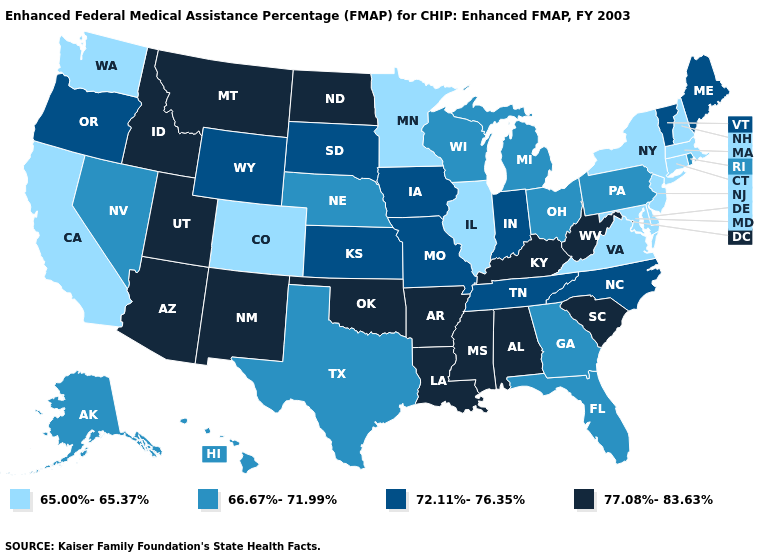Name the states that have a value in the range 77.08%-83.63%?
Keep it brief. Alabama, Arizona, Arkansas, Idaho, Kentucky, Louisiana, Mississippi, Montana, New Mexico, North Dakota, Oklahoma, South Carolina, Utah, West Virginia. What is the value of Rhode Island?
Keep it brief. 66.67%-71.99%. Which states have the highest value in the USA?
Write a very short answer. Alabama, Arizona, Arkansas, Idaho, Kentucky, Louisiana, Mississippi, Montana, New Mexico, North Dakota, Oklahoma, South Carolina, Utah, West Virginia. What is the value of New Mexico?
Write a very short answer. 77.08%-83.63%. Among the states that border Washington , which have the highest value?
Quick response, please. Idaho. What is the value of Washington?
Keep it brief. 65.00%-65.37%. Which states hav the highest value in the Northeast?
Be succinct. Maine, Vermont. What is the value of Illinois?
Write a very short answer. 65.00%-65.37%. Name the states that have a value in the range 77.08%-83.63%?
Give a very brief answer. Alabama, Arizona, Arkansas, Idaho, Kentucky, Louisiana, Mississippi, Montana, New Mexico, North Dakota, Oklahoma, South Carolina, Utah, West Virginia. What is the value of Iowa?
Write a very short answer. 72.11%-76.35%. Name the states that have a value in the range 66.67%-71.99%?
Give a very brief answer. Alaska, Florida, Georgia, Hawaii, Michigan, Nebraska, Nevada, Ohio, Pennsylvania, Rhode Island, Texas, Wisconsin. Name the states that have a value in the range 72.11%-76.35%?
Concise answer only. Indiana, Iowa, Kansas, Maine, Missouri, North Carolina, Oregon, South Dakota, Tennessee, Vermont, Wyoming. What is the highest value in states that border Pennsylvania?
Be succinct. 77.08%-83.63%. Does New Jersey have the highest value in the Northeast?
Answer briefly. No. Name the states that have a value in the range 72.11%-76.35%?
Keep it brief. Indiana, Iowa, Kansas, Maine, Missouri, North Carolina, Oregon, South Dakota, Tennessee, Vermont, Wyoming. 